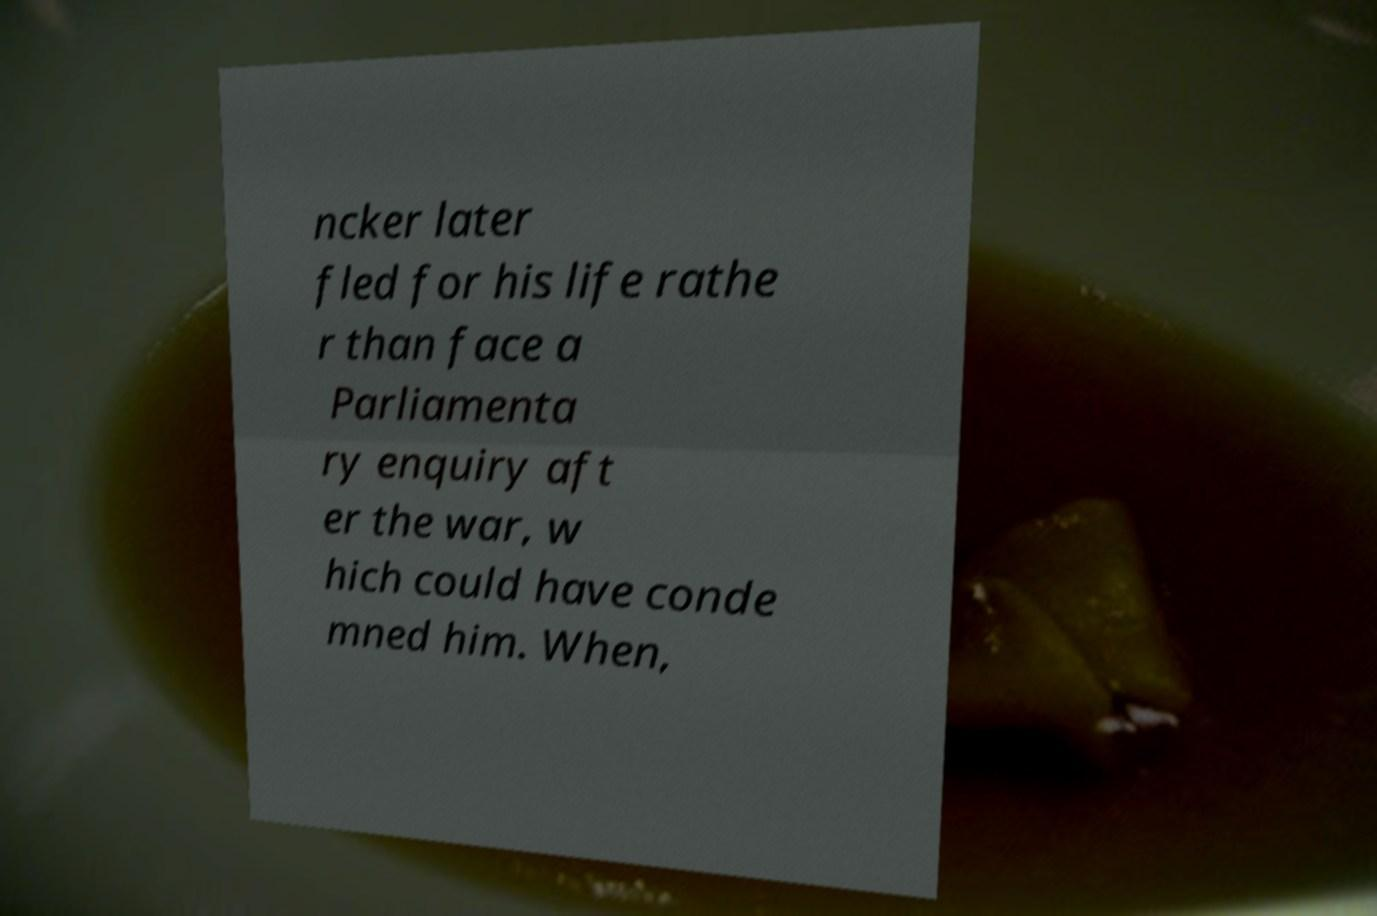Could you extract and type out the text from this image? ncker later fled for his life rathe r than face a Parliamenta ry enquiry aft er the war, w hich could have conde mned him. When, 